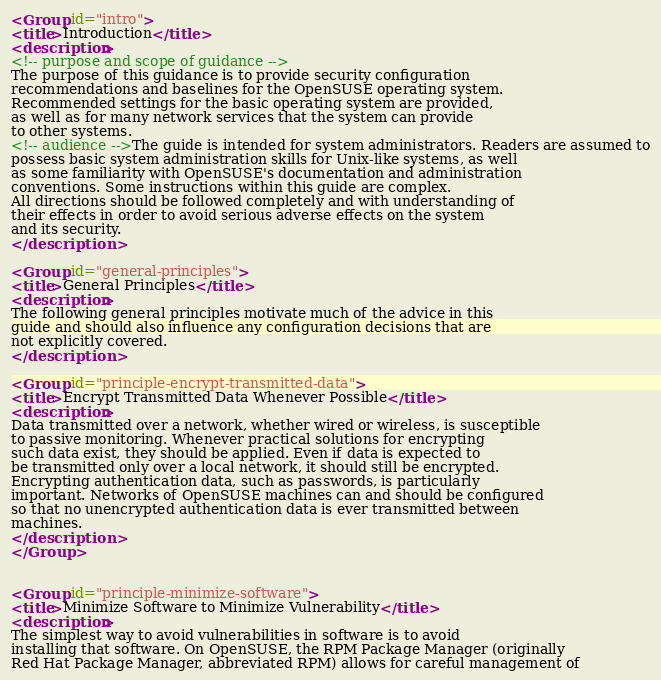<code> <loc_0><loc_0><loc_500><loc_500><_XML_><Group id="intro">
<title>Introduction</title>
<description>
<!-- purpose and scope of guidance -->
The purpose of this guidance is to provide security configuration
recommendations and baselines for the OpenSUSE operating system.
Recommended settings for the basic operating system are provided,
as well as for many network services that the system can provide
to other systems.
<!-- audience -->The guide is intended for system administrators. Readers are assumed to
possess basic system administration skills for Unix-like systems, as well
as some familiarity with OpenSUSE's documentation and administration
conventions. Some instructions within this guide are complex.
All directions should be followed completely and with understanding of
their effects in order to avoid serious adverse effects on the system
and its security.
</description>

<Group id="general-principles">
<title>General Principles</title>
<description>
The following general principles motivate much of the advice in this
guide and should also influence any configuration decisions that are
not explicitly covered.
</description>

<Group id="principle-encrypt-transmitted-data">
<title>Encrypt Transmitted Data Whenever Possible</title>
<description>
Data transmitted over a network, whether wired or wireless, is susceptible
to passive monitoring. Whenever practical solutions for encrypting
such data exist, they should be applied. Even if data is expected to
be transmitted only over a local network, it should still be encrypted.
Encrypting authentication data, such as passwords, is particularly
important. Networks of OpenSUSE machines can and should be configured
so that no unencrypted authentication data is ever transmitted between
machines.
</description>
</Group>


<Group id="principle-minimize-software">
<title>Minimize Software to Minimize Vulnerability</title>
<description>
The simplest way to avoid vulnerabilities in software is to avoid
installing that software. On OpenSUSE, the RPM Package Manager (originally
Red Hat Package Manager, abbreviated RPM) allows for careful management of</code> 